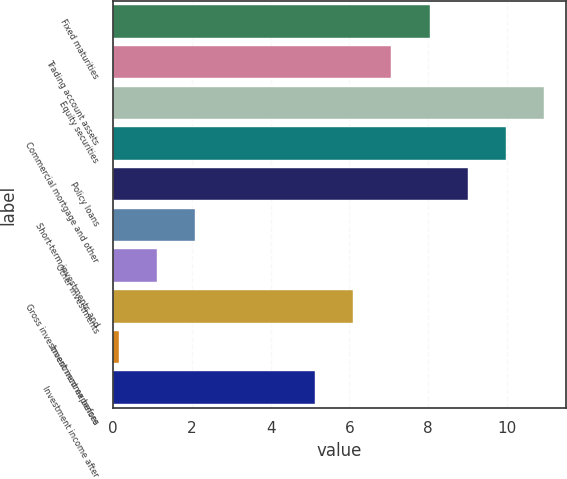<chart> <loc_0><loc_0><loc_500><loc_500><bar_chart><fcel>Fixed maturities<fcel>Trading account assets<fcel>Equity securities<fcel>Commercial mortgage and other<fcel>Policy loans<fcel>Short-term investments and<fcel>Other investments<fcel>Gross investment income before<fcel>Investment expenses<fcel>Investment income after<nl><fcel>8.04<fcel>7.07<fcel>10.95<fcel>9.98<fcel>9.01<fcel>2.08<fcel>1.11<fcel>6.1<fcel>0.14<fcel>5.13<nl></chart> 